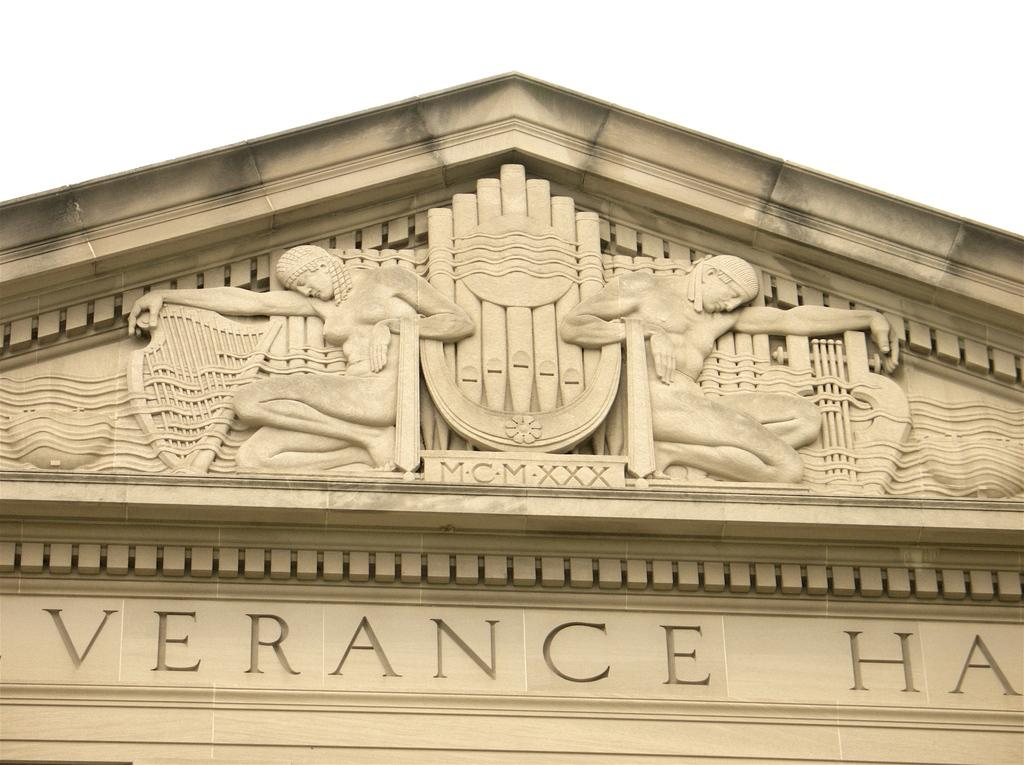What is the main subject of the image? The main subject of the image is a stone carving. How many ladybugs can be seen crawling on the stone carving in the image? There are no ladybugs present in the image; it features a stone carving. What type of game is being played on the stone carving in the image? There is no game, such as chess, being played on the stone carving in the image. 